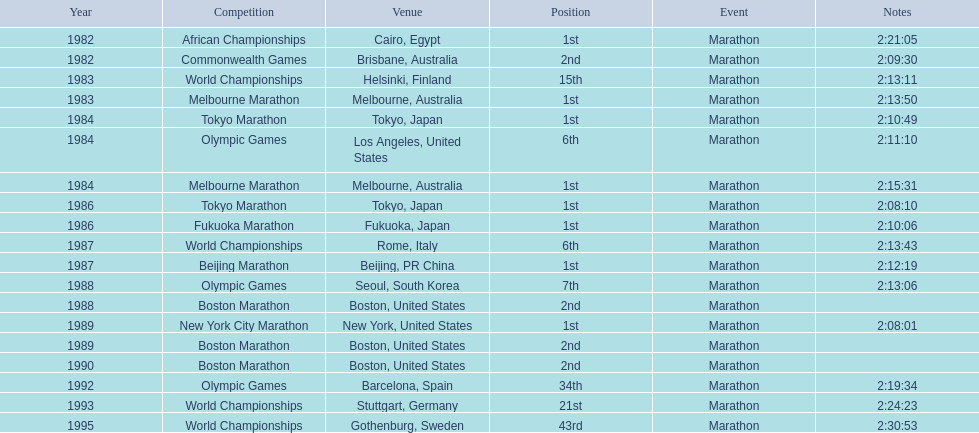What are the various juma ikangaa competitions? African Championships, Commonwealth Games, World Championships, Melbourne Marathon, Tokyo Marathon, Olympic Games, Melbourne Marathon, Tokyo Marathon, Fukuoka Marathon, World Championships, Beijing Marathon, Olympic Games, Boston Marathon, New York City Marathon, Boston Marathon, Boston Marathon, Olympic Games, World Championships, World Championships. Among them, which ones were not held in the united states? African Championships, Commonwealth Games, World Championships, Melbourne Marathon, Tokyo Marathon, Melbourne Marathon, Tokyo Marathon, Fukuoka Marathon, World Championships, Beijing Marathon, Olympic Games, Olympic Games, World Championships, World Championships. From those, which ones were conducted in asia? Tokyo Marathon, Tokyo Marathon, Fukuoka Marathon, Beijing Marathon, Olympic Games. Lastly, which of the remaining events occurred in china? Beijing Marathon. 